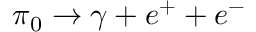<formula> <loc_0><loc_0><loc_500><loc_500>\pi _ { 0 } \rightarrow \gamma + e ^ { + } + e ^ { - }</formula> 